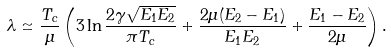Convert formula to latex. <formula><loc_0><loc_0><loc_500><loc_500>\lambda \simeq \frac { T _ { c } } { \mu } \left ( 3 \ln \frac { 2 \gamma \sqrt { E _ { 1 } E _ { 2 } } } { \pi T _ { c } } + \frac { 2 \mu ( E _ { 2 } - E _ { 1 } ) } { E _ { 1 } E _ { 2 } } + \frac { E _ { 1 } - E _ { 2 } } { 2 \mu } \right ) .</formula> 